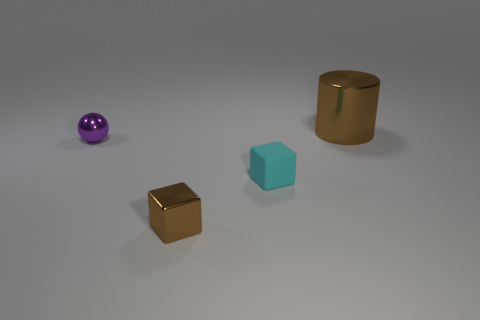Add 1 big brown metallic things. How many objects exist? 5 Subtract all spheres. How many objects are left? 3 Subtract all tiny purple spheres. Subtract all rubber cubes. How many objects are left? 2 Add 4 large cylinders. How many large cylinders are left? 5 Add 1 large brown metallic cylinders. How many large brown metallic cylinders exist? 2 Subtract 0 brown spheres. How many objects are left? 4 